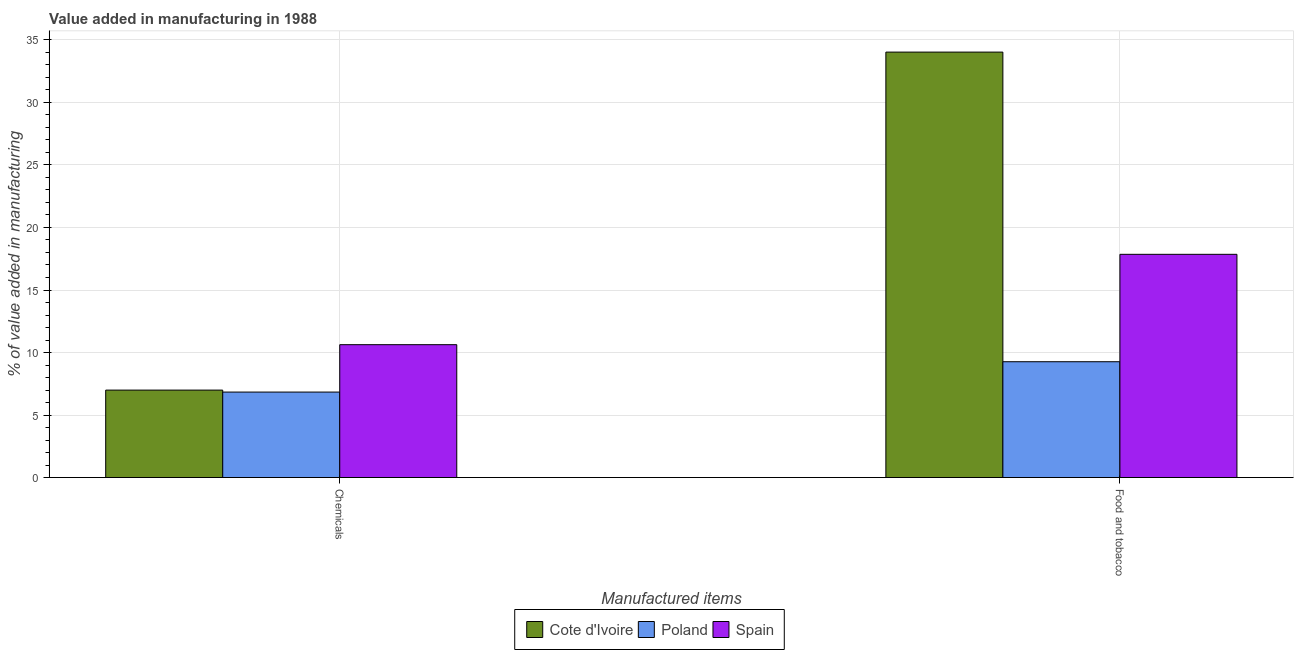How many different coloured bars are there?
Ensure brevity in your answer.  3. How many groups of bars are there?
Keep it short and to the point. 2. How many bars are there on the 1st tick from the left?
Provide a succinct answer. 3. How many bars are there on the 2nd tick from the right?
Ensure brevity in your answer.  3. What is the label of the 1st group of bars from the left?
Your answer should be very brief. Chemicals. What is the value added by  manufacturing chemicals in Cote d'Ivoire?
Provide a short and direct response. 6.99. Across all countries, what is the maximum value added by  manufacturing chemicals?
Your response must be concise. 10.63. Across all countries, what is the minimum value added by manufacturing food and tobacco?
Keep it short and to the point. 9.26. In which country was the value added by manufacturing food and tobacco maximum?
Keep it short and to the point. Cote d'Ivoire. In which country was the value added by manufacturing food and tobacco minimum?
Provide a succinct answer. Poland. What is the total value added by manufacturing food and tobacco in the graph?
Provide a short and direct response. 61.14. What is the difference between the value added by manufacturing food and tobacco in Cote d'Ivoire and that in Spain?
Provide a short and direct response. 16.17. What is the difference between the value added by manufacturing food and tobacco in Cote d'Ivoire and the value added by  manufacturing chemicals in Poland?
Your response must be concise. 27.19. What is the average value added by  manufacturing chemicals per country?
Make the answer very short. 8.15. What is the difference between the value added by  manufacturing chemicals and value added by manufacturing food and tobacco in Spain?
Your answer should be very brief. -7.23. What is the ratio of the value added by  manufacturing chemicals in Poland to that in Cote d'Ivoire?
Provide a succinct answer. 0.98. What does the 1st bar from the left in Food and tobacco represents?
Keep it short and to the point. Cote d'Ivoire. What does the 2nd bar from the right in Food and tobacco represents?
Your answer should be very brief. Poland. How many bars are there?
Offer a very short reply. 6. Are the values on the major ticks of Y-axis written in scientific E-notation?
Offer a very short reply. No. How many legend labels are there?
Your answer should be compact. 3. How are the legend labels stacked?
Offer a terse response. Horizontal. What is the title of the graph?
Provide a succinct answer. Value added in manufacturing in 1988. Does "Small states" appear as one of the legend labels in the graph?
Provide a short and direct response. No. What is the label or title of the X-axis?
Offer a terse response. Manufactured items. What is the label or title of the Y-axis?
Provide a short and direct response. % of value added in manufacturing. What is the % of value added in manufacturing in Cote d'Ivoire in Chemicals?
Ensure brevity in your answer.  6.99. What is the % of value added in manufacturing of Poland in Chemicals?
Your answer should be compact. 6.84. What is the % of value added in manufacturing in Spain in Chemicals?
Your answer should be compact. 10.63. What is the % of value added in manufacturing of Cote d'Ivoire in Food and tobacco?
Your answer should be very brief. 34.03. What is the % of value added in manufacturing of Poland in Food and tobacco?
Offer a very short reply. 9.26. What is the % of value added in manufacturing of Spain in Food and tobacco?
Your answer should be compact. 17.85. Across all Manufactured items, what is the maximum % of value added in manufacturing of Cote d'Ivoire?
Keep it short and to the point. 34.03. Across all Manufactured items, what is the maximum % of value added in manufacturing in Poland?
Your answer should be very brief. 9.26. Across all Manufactured items, what is the maximum % of value added in manufacturing in Spain?
Ensure brevity in your answer.  17.85. Across all Manufactured items, what is the minimum % of value added in manufacturing in Cote d'Ivoire?
Your response must be concise. 6.99. Across all Manufactured items, what is the minimum % of value added in manufacturing of Poland?
Offer a very short reply. 6.84. Across all Manufactured items, what is the minimum % of value added in manufacturing of Spain?
Your answer should be compact. 10.63. What is the total % of value added in manufacturing in Cote d'Ivoire in the graph?
Provide a short and direct response. 41.02. What is the total % of value added in manufacturing of Poland in the graph?
Your response must be concise. 16.1. What is the total % of value added in manufacturing of Spain in the graph?
Provide a succinct answer. 28.48. What is the difference between the % of value added in manufacturing of Cote d'Ivoire in Chemicals and that in Food and tobacco?
Your answer should be compact. -27.03. What is the difference between the % of value added in manufacturing of Poland in Chemicals and that in Food and tobacco?
Ensure brevity in your answer.  -2.43. What is the difference between the % of value added in manufacturing of Spain in Chemicals and that in Food and tobacco?
Offer a very short reply. -7.23. What is the difference between the % of value added in manufacturing in Cote d'Ivoire in Chemicals and the % of value added in manufacturing in Poland in Food and tobacco?
Keep it short and to the point. -2.27. What is the difference between the % of value added in manufacturing of Cote d'Ivoire in Chemicals and the % of value added in manufacturing of Spain in Food and tobacco?
Your response must be concise. -10.86. What is the difference between the % of value added in manufacturing in Poland in Chemicals and the % of value added in manufacturing in Spain in Food and tobacco?
Keep it short and to the point. -11.02. What is the average % of value added in manufacturing of Cote d'Ivoire per Manufactured items?
Offer a terse response. 20.51. What is the average % of value added in manufacturing in Poland per Manufactured items?
Make the answer very short. 8.05. What is the average % of value added in manufacturing of Spain per Manufactured items?
Your answer should be very brief. 14.24. What is the difference between the % of value added in manufacturing in Cote d'Ivoire and % of value added in manufacturing in Poland in Chemicals?
Make the answer very short. 0.16. What is the difference between the % of value added in manufacturing of Cote d'Ivoire and % of value added in manufacturing of Spain in Chemicals?
Provide a short and direct response. -3.63. What is the difference between the % of value added in manufacturing in Poland and % of value added in manufacturing in Spain in Chemicals?
Keep it short and to the point. -3.79. What is the difference between the % of value added in manufacturing in Cote d'Ivoire and % of value added in manufacturing in Poland in Food and tobacco?
Keep it short and to the point. 24.76. What is the difference between the % of value added in manufacturing of Cote d'Ivoire and % of value added in manufacturing of Spain in Food and tobacco?
Provide a short and direct response. 16.17. What is the difference between the % of value added in manufacturing of Poland and % of value added in manufacturing of Spain in Food and tobacco?
Make the answer very short. -8.59. What is the ratio of the % of value added in manufacturing of Cote d'Ivoire in Chemicals to that in Food and tobacco?
Your response must be concise. 0.21. What is the ratio of the % of value added in manufacturing in Poland in Chemicals to that in Food and tobacco?
Keep it short and to the point. 0.74. What is the ratio of the % of value added in manufacturing of Spain in Chemicals to that in Food and tobacco?
Ensure brevity in your answer.  0.6. What is the difference between the highest and the second highest % of value added in manufacturing in Cote d'Ivoire?
Keep it short and to the point. 27.03. What is the difference between the highest and the second highest % of value added in manufacturing of Poland?
Make the answer very short. 2.43. What is the difference between the highest and the second highest % of value added in manufacturing in Spain?
Provide a short and direct response. 7.23. What is the difference between the highest and the lowest % of value added in manufacturing in Cote d'Ivoire?
Keep it short and to the point. 27.03. What is the difference between the highest and the lowest % of value added in manufacturing of Poland?
Provide a succinct answer. 2.43. What is the difference between the highest and the lowest % of value added in manufacturing of Spain?
Your response must be concise. 7.23. 